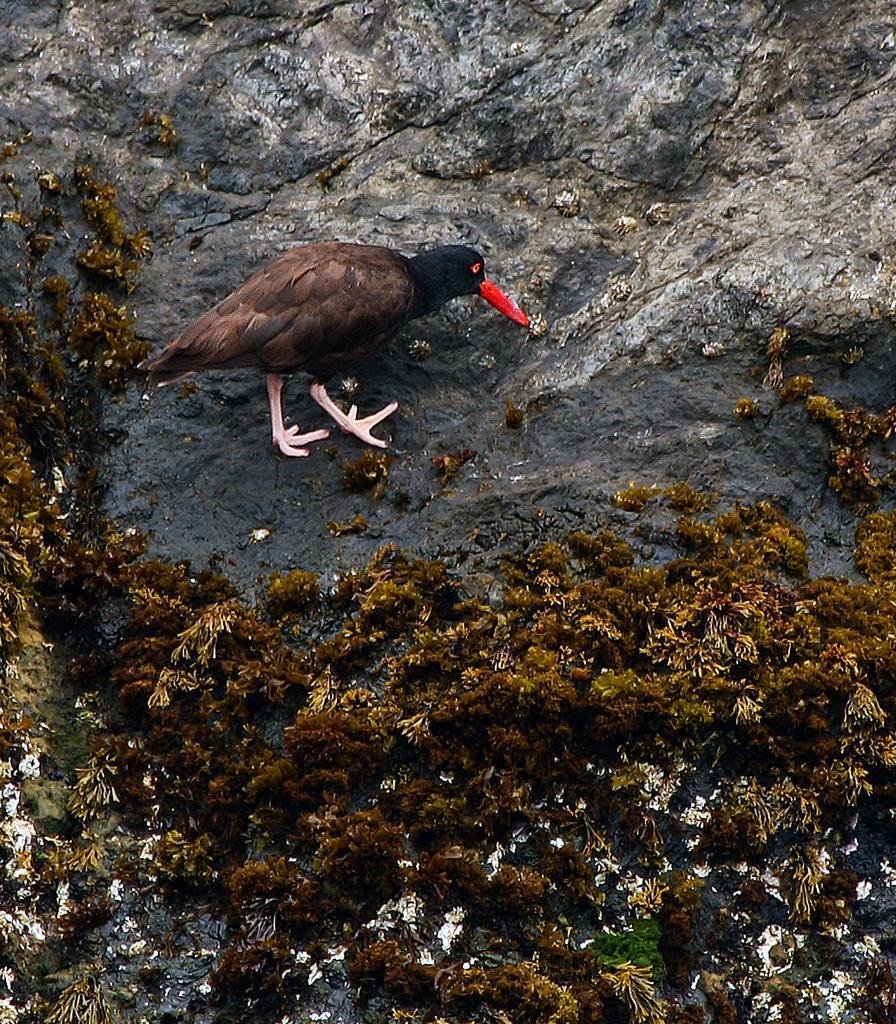In one or two sentences, can you explain what this image depicts? In this image I can see the grass on the bottom of the picture and I see a bird in the middle of the picture and I see the stone. 